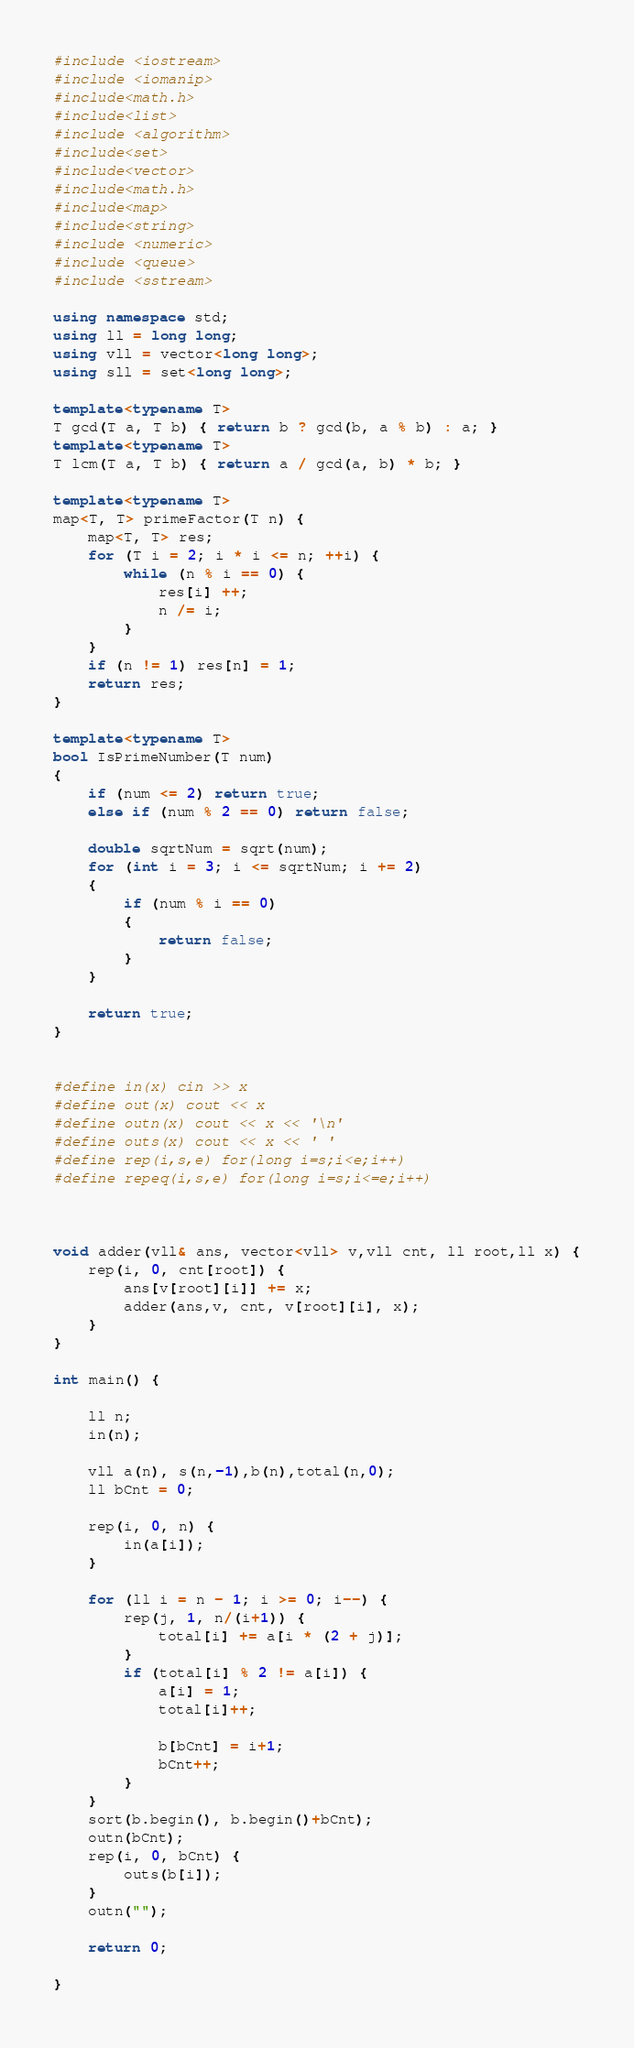<code> <loc_0><loc_0><loc_500><loc_500><_C++_>#include <iostream>
#include <iomanip>
#include<math.h>
#include<list>
#include <algorithm>
#include<set>
#include<vector>
#include<math.h>
#include<map>
#include<string>
#include <numeric>
#include <queue>
#include <sstream>

using namespace std;
using ll = long long;
using vll = vector<long long>;
using sll = set<long long>;

template<typename T>
T gcd(T a, T b) { return b ? gcd(b, a % b) : a; }
template<typename T>
T lcm(T a, T b) { return a / gcd(a, b) * b; }

template<typename T>
map<T, T> primeFactor(T n) {
	map<T, T> res;
	for (T i = 2; i * i <= n; ++i) {
		while (n % i == 0) {
			res[i] ++;
			n /= i;
		}
	}
	if (n != 1) res[n] = 1;
	return res;
}

template<typename T>
bool IsPrimeNumber(T num)
{
	if (num <= 2) return true;
	else if (num % 2 == 0) return false;

	double sqrtNum = sqrt(num);
	for (int i = 3; i <= sqrtNum; i += 2)
	{
		if (num % i == 0)
		{
			return false;
		}
	}

	return true;
}


#define in(x) cin >> x
#define out(x) cout << x
#define outn(x) cout << x << '\n'
#define outs(x) cout << x << ' '
#define rep(i,s,e) for(long i=s;i<e;i++)
#define repeq(i,s,e) for(long i=s;i<=e;i++)



void adder(vll& ans, vector<vll> v,vll cnt, ll root,ll x) {
	rep(i, 0, cnt[root]) {
		ans[v[root][i]] += x;
		adder(ans,v, cnt, v[root][i], x);
	}
}

int main() {

	ll n;
	in(n);

	vll a(n), s(n,-1),b(n),total(n,0);
	ll bCnt = 0;

	rep(i, 0, n) {
		in(a[i]);
	}

	for (ll i = n - 1; i >= 0; i--) {
		rep(j, 1, n/(i+1)) {
			total[i] += a[i * (2 + j)];
		}
		if (total[i] % 2 != a[i]) {
			a[i] = 1;
			total[i]++;

			b[bCnt] = i+1;
			bCnt++;
		}
	}
	sort(b.begin(), b.begin()+bCnt);
	outn(bCnt);
	rep(i, 0, bCnt) {
		outs(b[i]);
	}
	outn("");

	return 0;

}
</code> 